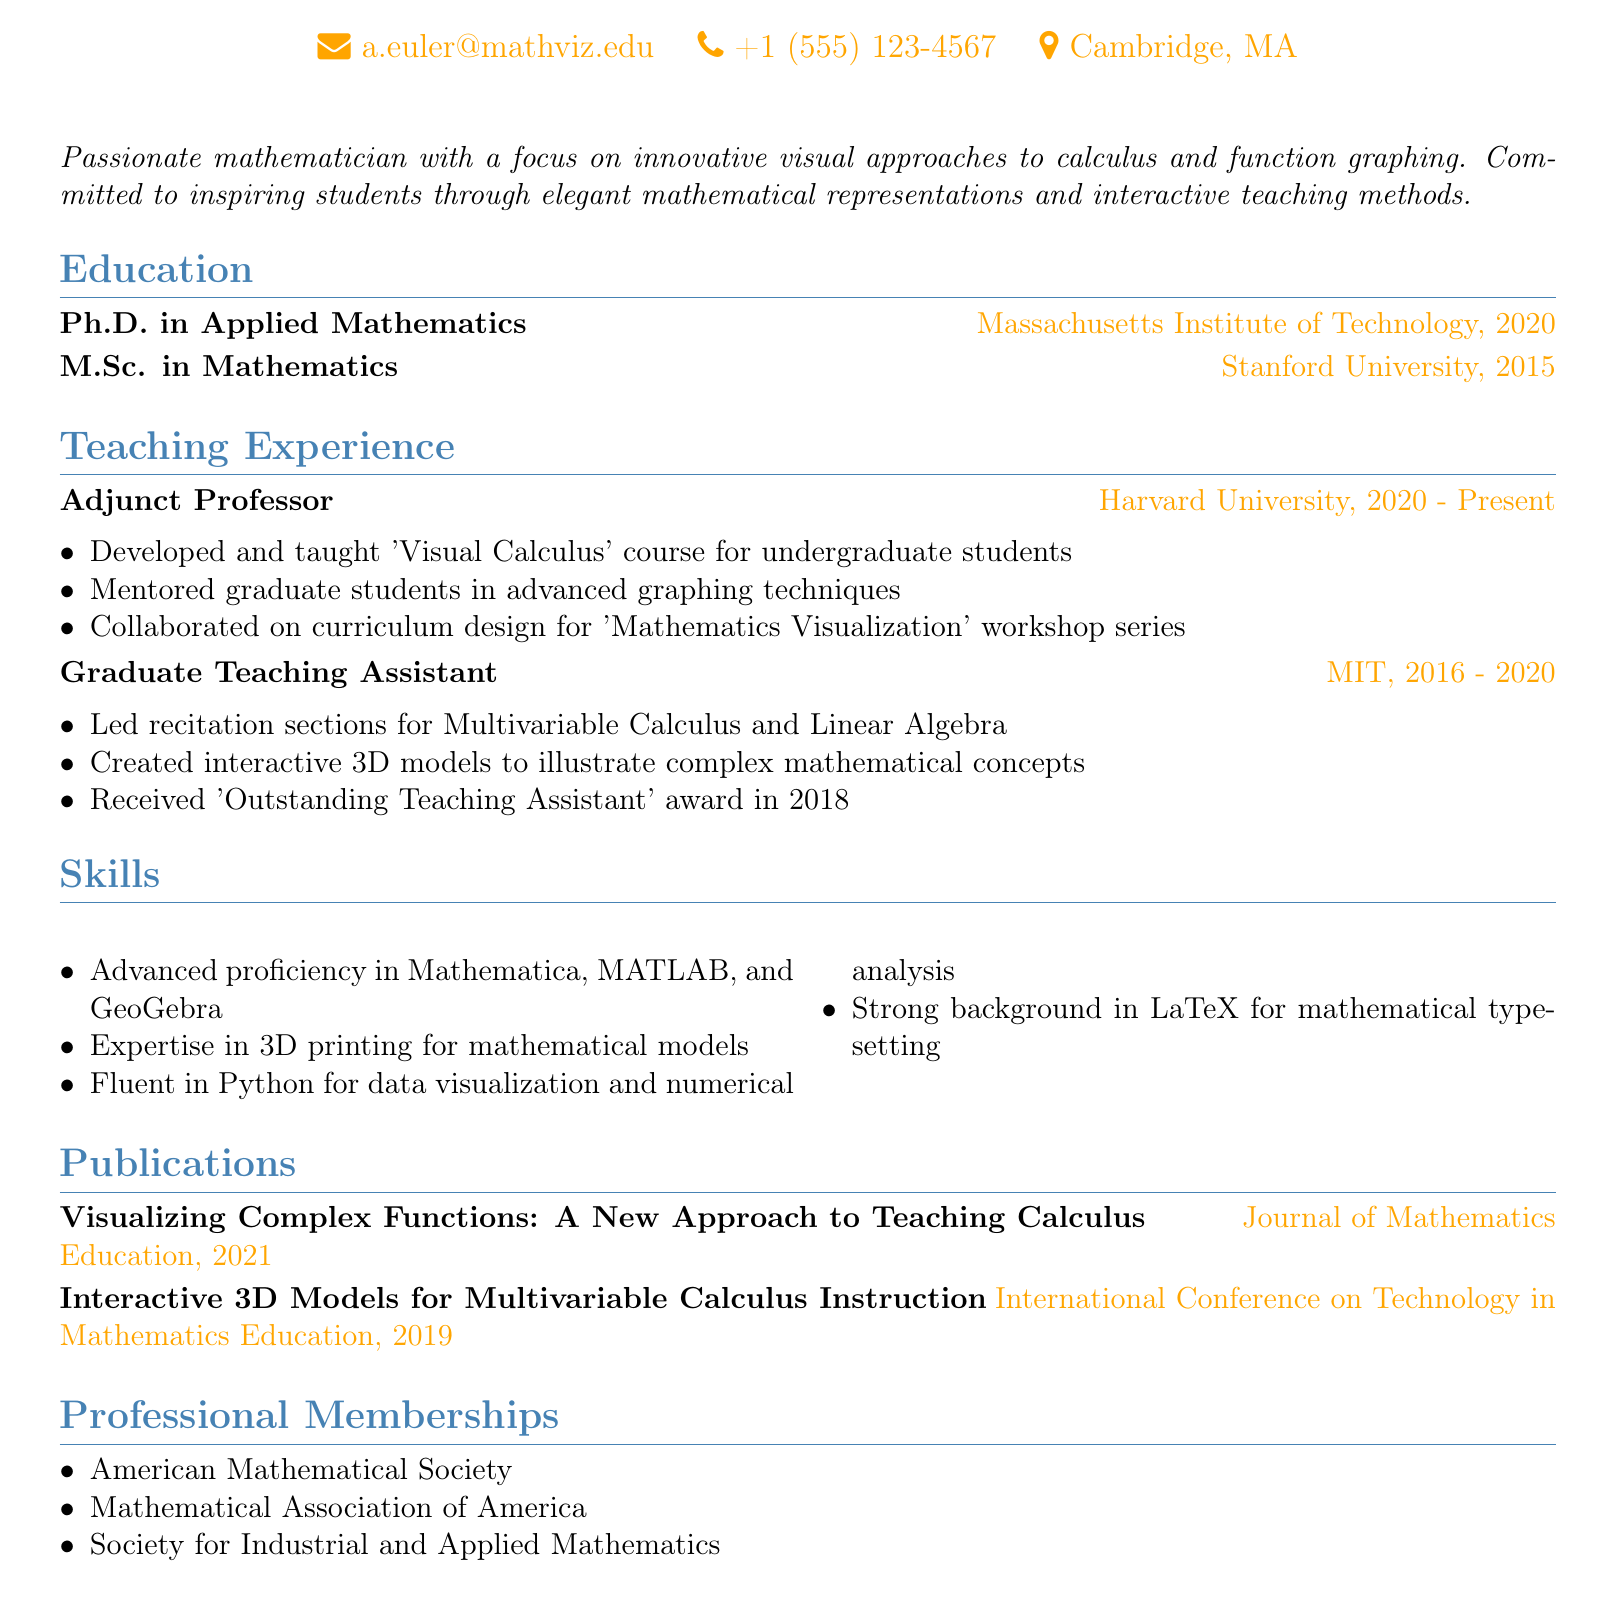What is Alexandra Euler's email address? The email address is explicitly stated in the personal information section of the curriculum vitae.
Answer: a.euler@mathviz.edu How many years did Alexandra serve as a Graduate Teaching Assistant? The duration of her role as a Graduate Teaching Assistant is from 2016 to 2020, which totals four years.
Answer: 4 years What is the title of Alexandra's doctoral degree? The degree title is mentioned under the education section, specifying the Ph.D. she obtained.
Answer: Ph.D. in Applied Mathematics Which course did Alexandra teach at Harvard University? The course title is listed in the teaching experience section where she mentions her duties as an Adjunct Professor.
Answer: Visual Calculus In what year did Alexandra receive the 'Outstanding Teaching Assistant' award? This award year is specifically noted in the responsibilities of her role as a Graduate Teaching Assistant.
Answer: 2018 How many professional memberships does Alexandra have listed? The document itemizes her professional memberships, which can be counted for a total.
Answer: 3 memberships What innovative approach is highlighted in Alexandra's publications? The title of her publication indicates a focus on an innovative approach to a specific subject, which is pivotal.
Answer: Visualizing Complex Functions What is one of the programming skills Alexandra possesses? This information is derived from the skills section of the CV, stating programming languages she knows well.
Answer: Python 